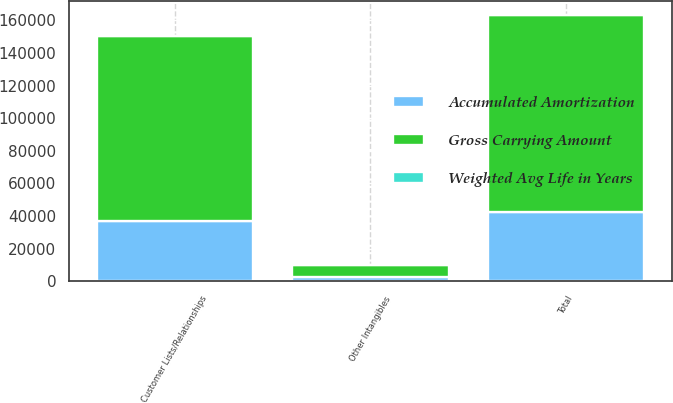Convert chart to OTSL. <chart><loc_0><loc_0><loc_500><loc_500><stacked_bar_chart><ecel><fcel>Customer Lists/Relationships<fcel>Other Intangibles<fcel>Total<nl><fcel>Gross Carrying Amount<fcel>113739<fcel>6957<fcel>120696<nl><fcel>Accumulated Amortization<fcel>36744<fcel>2817<fcel>42615<nl><fcel>Weighted Avg Life in Years<fcel>12.7<fcel>6.3<fcel>12.3<nl></chart> 